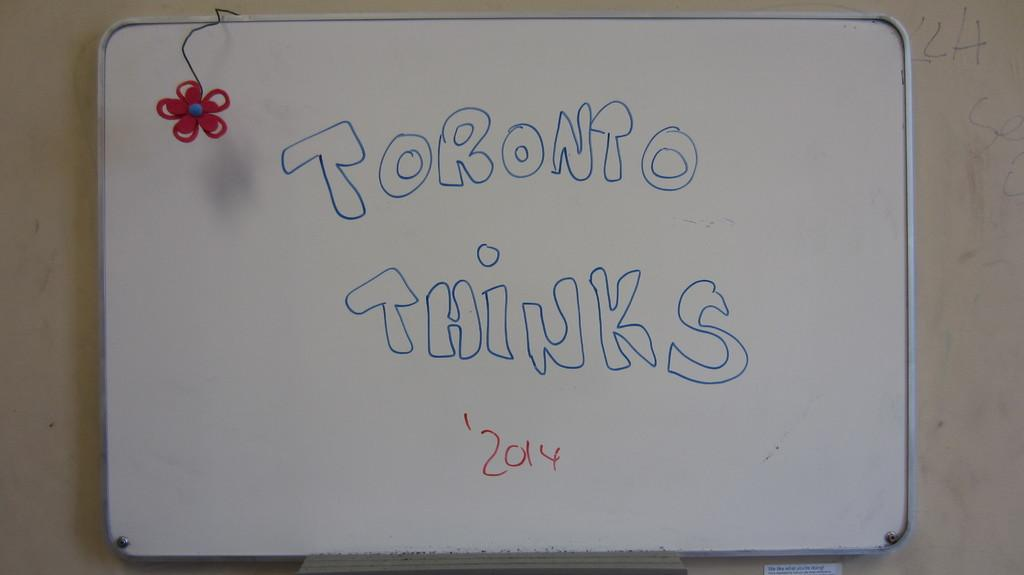<image>
Describe the image concisely. A white board has the words Toronto Thinks on it in blue. 